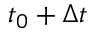<formula> <loc_0><loc_0><loc_500><loc_500>t _ { 0 } + \Delta t</formula> 